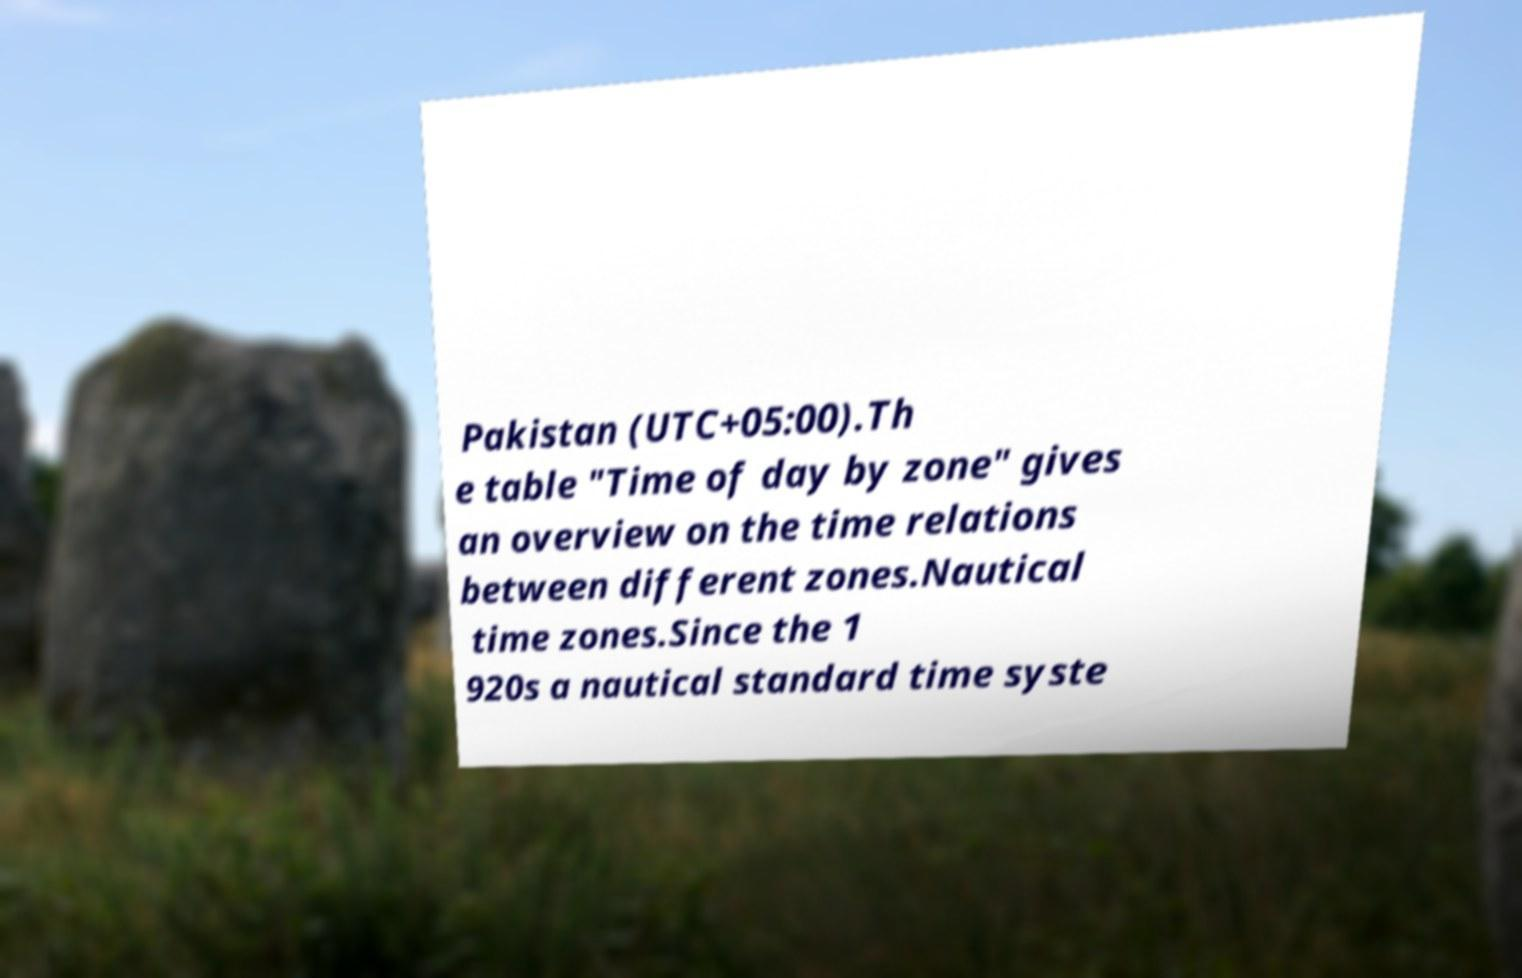Please read and relay the text visible in this image. What does it say? Pakistan (UTC+05:00).Th e table "Time of day by zone" gives an overview on the time relations between different zones.Nautical time zones.Since the 1 920s a nautical standard time syste 